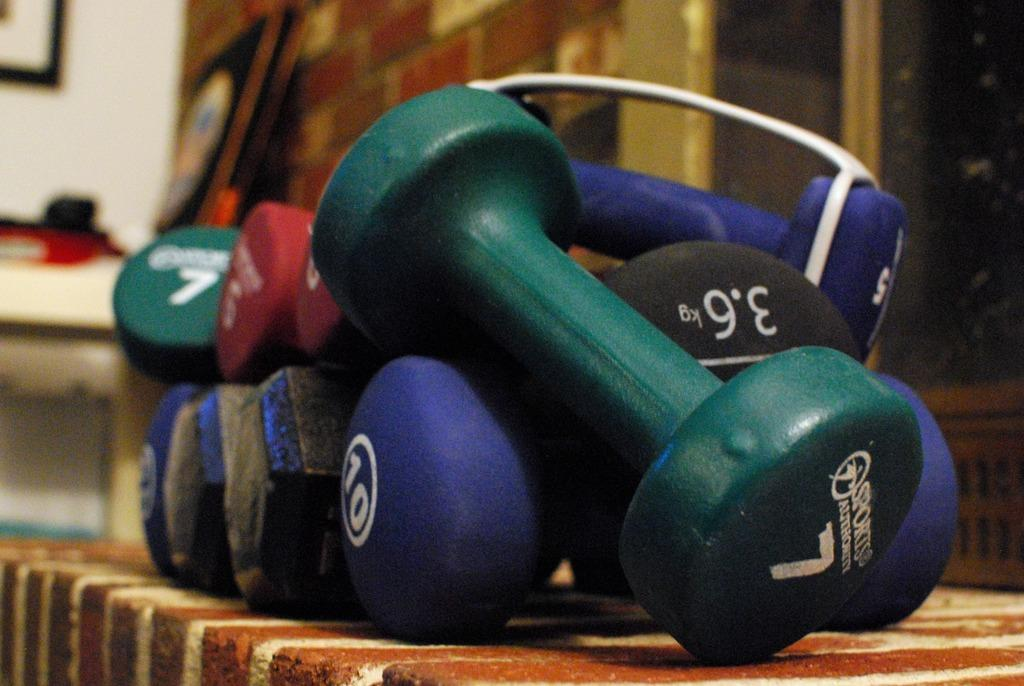What can be seen in the image? There are objects in the image. Are there any words or letters on the objects? Yes, there is text on some of the objects. Where are the objects located in the image? There are objects on the left side of the image. What is hanging on the wall at the top left of the image? There is a photo on the wall at the top left of the image. Can you tell me how many times the person in the image jumps in the field? There is no person jumping in a field in the image; it only contains objects and a photo on the wall. 